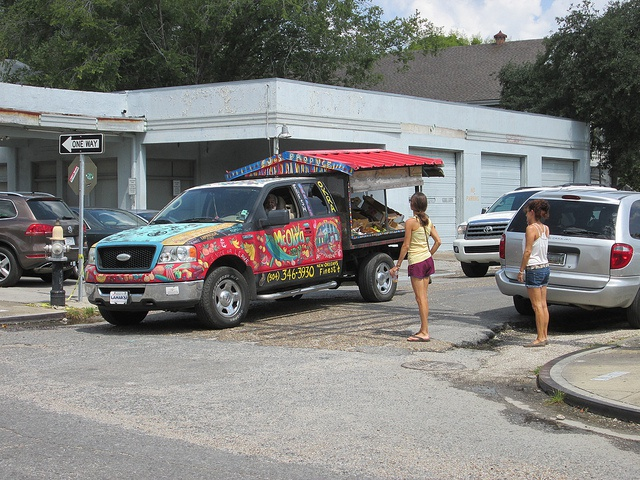Describe the objects in this image and their specific colors. I can see truck in black, gray, darkgray, and blue tones, car in black, gray, darkgray, and lightgray tones, car in black, gray, and darkgray tones, truck in black, lightgray, darkgray, and gray tones, and people in black, gray, tan, and khaki tones in this image. 